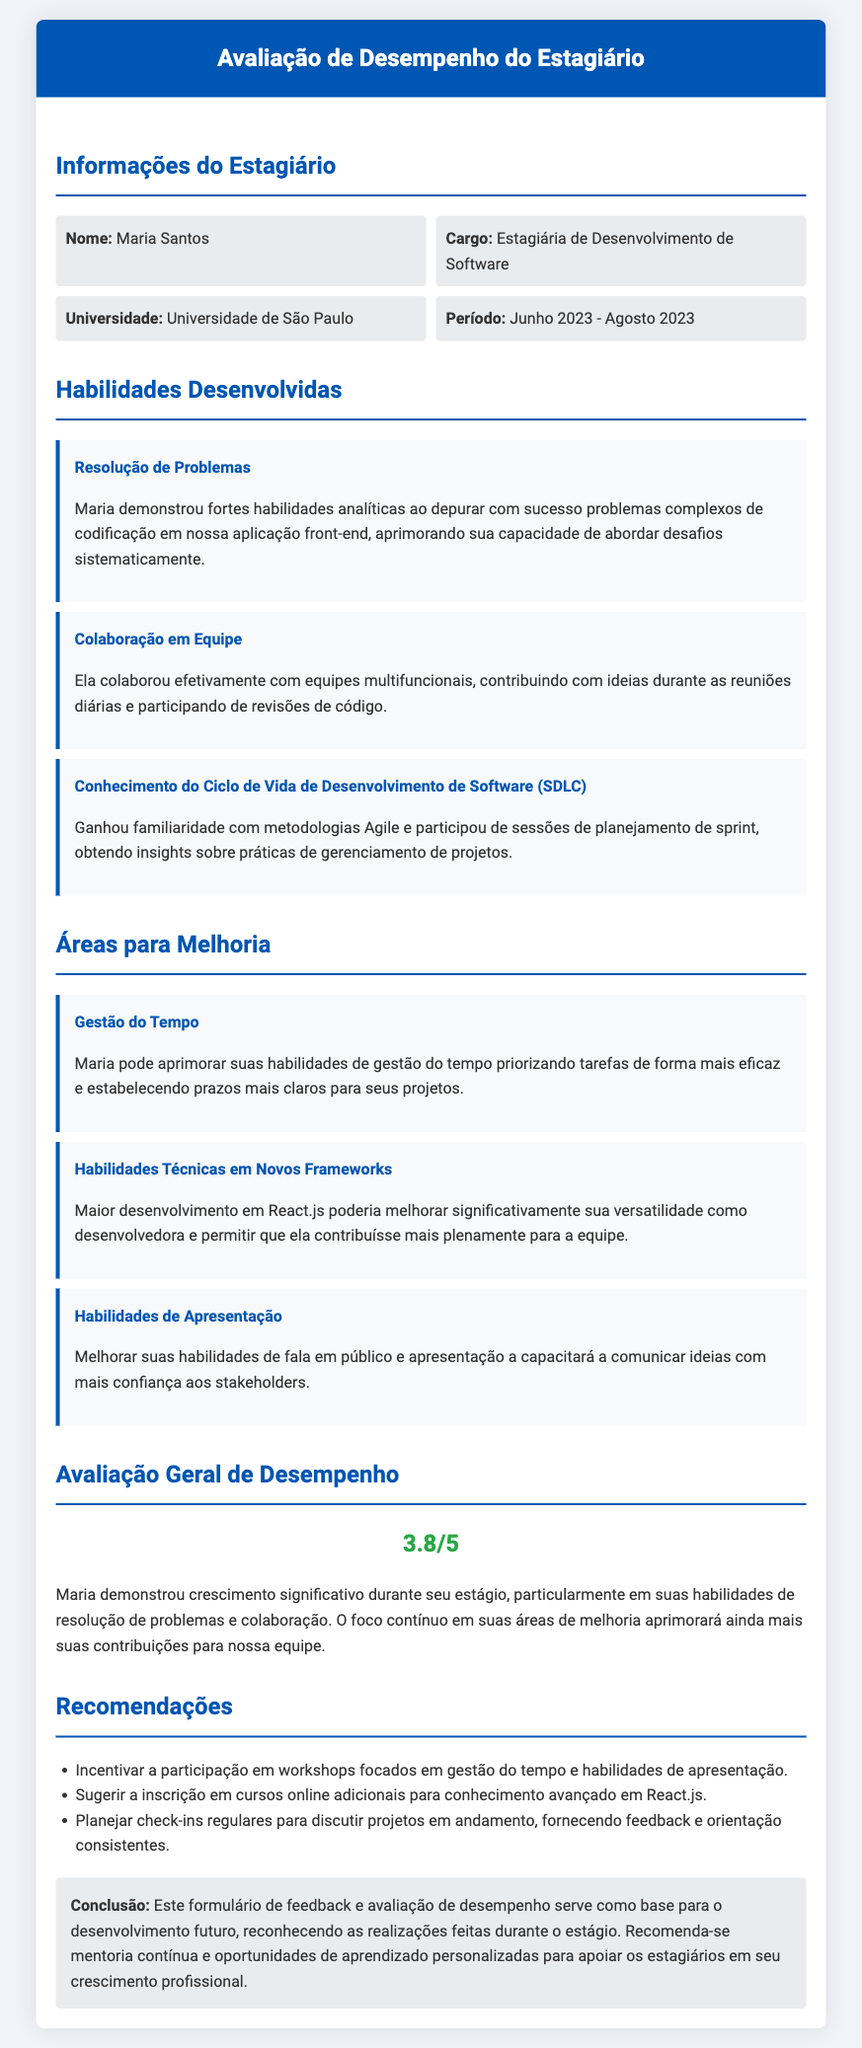Qual é o nome da estagiária? O nome da estagiária é a primeira informação apresentada no documento.
Answer: Maria Santos Qual o cargo da estagiária? O cargo da estagiária é mencionado logo após o nome.
Answer: Estagiária de Desenvolvimento de Software Qual a universidade da estagiária? A universidade onde a estagiária estuda é listada na seção de informações.
Answer: Universidade de São Paulo Qual foi o período do estágio? O período do estágio é especificado na seção de informações.
Answer: Junho 2023 - Agosto 2023 Qual é a classificação geral de desempenho da estagiária? A avaliação geral de desempenho é apresentada em uma seção específica.
Answer: 3.8/5 Quais habilidades Maria desenvolveu relacionadas à colaboração? A habilidade desenvolvida que menciona colaboração é descrita em detalhes no documento.
Answer: Colaboração em Equipe Qual área de melhoria requer maior desenvolvimento em React.js? A área específica para melhoria é mencionada na seção correspondente.
Answer: Habilidades Técnicas em Novos Frameworks Quais recomendações foram feitas para Maria? As recomendações são listadas como sugestões para o desenvolvimento futuro.
Answer: Workshops focados em gestão do tempo e habilidades de apresentação Qual a conclusão sobre o estágio de Maria? A conclusão é uma afirmação sobre o estágio e desenvolvimento da estagiária.
Answer: Base para o desenvolvimento futuro 